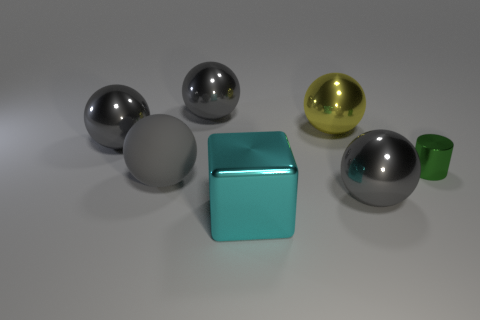How many other large things are the same color as the big matte object?
Your response must be concise. 3. The metal cylinder has what color?
Offer a terse response. Green. Is the shape of the object that is to the left of the gray matte ball the same as  the cyan metal object?
Provide a succinct answer. No. What is the shape of the large thing that is in front of the gray metallic sphere that is in front of the gray ball that is left of the matte ball?
Make the answer very short. Cube. There is a big ball that is to the left of the matte thing; what is it made of?
Give a very brief answer. Metal. What color is the block that is the same size as the matte thing?
Provide a short and direct response. Cyan. How many other things are the same shape as the big gray matte thing?
Provide a short and direct response. 4. Is the size of the green cylinder the same as the cyan metal block?
Provide a short and direct response. No. Is the number of gray shiny things that are left of the large block greater than the number of large balls that are right of the small green object?
Provide a short and direct response. Yes. What number of other things are there of the same size as the green shiny cylinder?
Offer a very short reply. 0. 